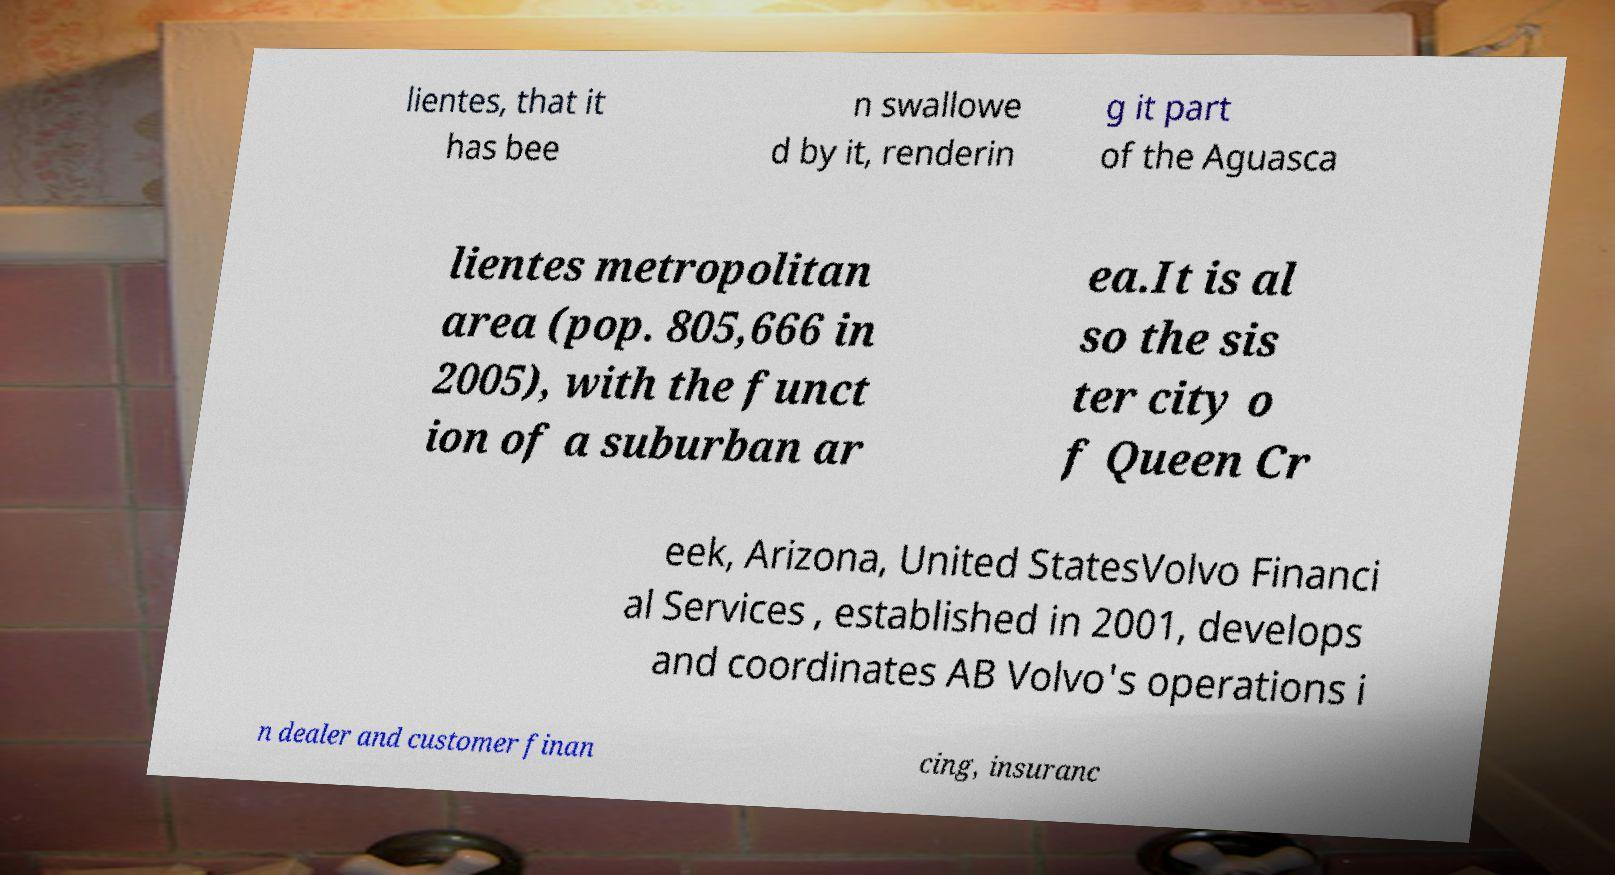Please read and relay the text visible in this image. What does it say? lientes, that it has bee n swallowe d by it, renderin g it part of the Aguasca lientes metropolitan area (pop. 805,666 in 2005), with the funct ion of a suburban ar ea.It is al so the sis ter city o f Queen Cr eek, Arizona, United StatesVolvo Financi al Services , established in 2001, develops and coordinates AB Volvo's operations i n dealer and customer finan cing, insuranc 